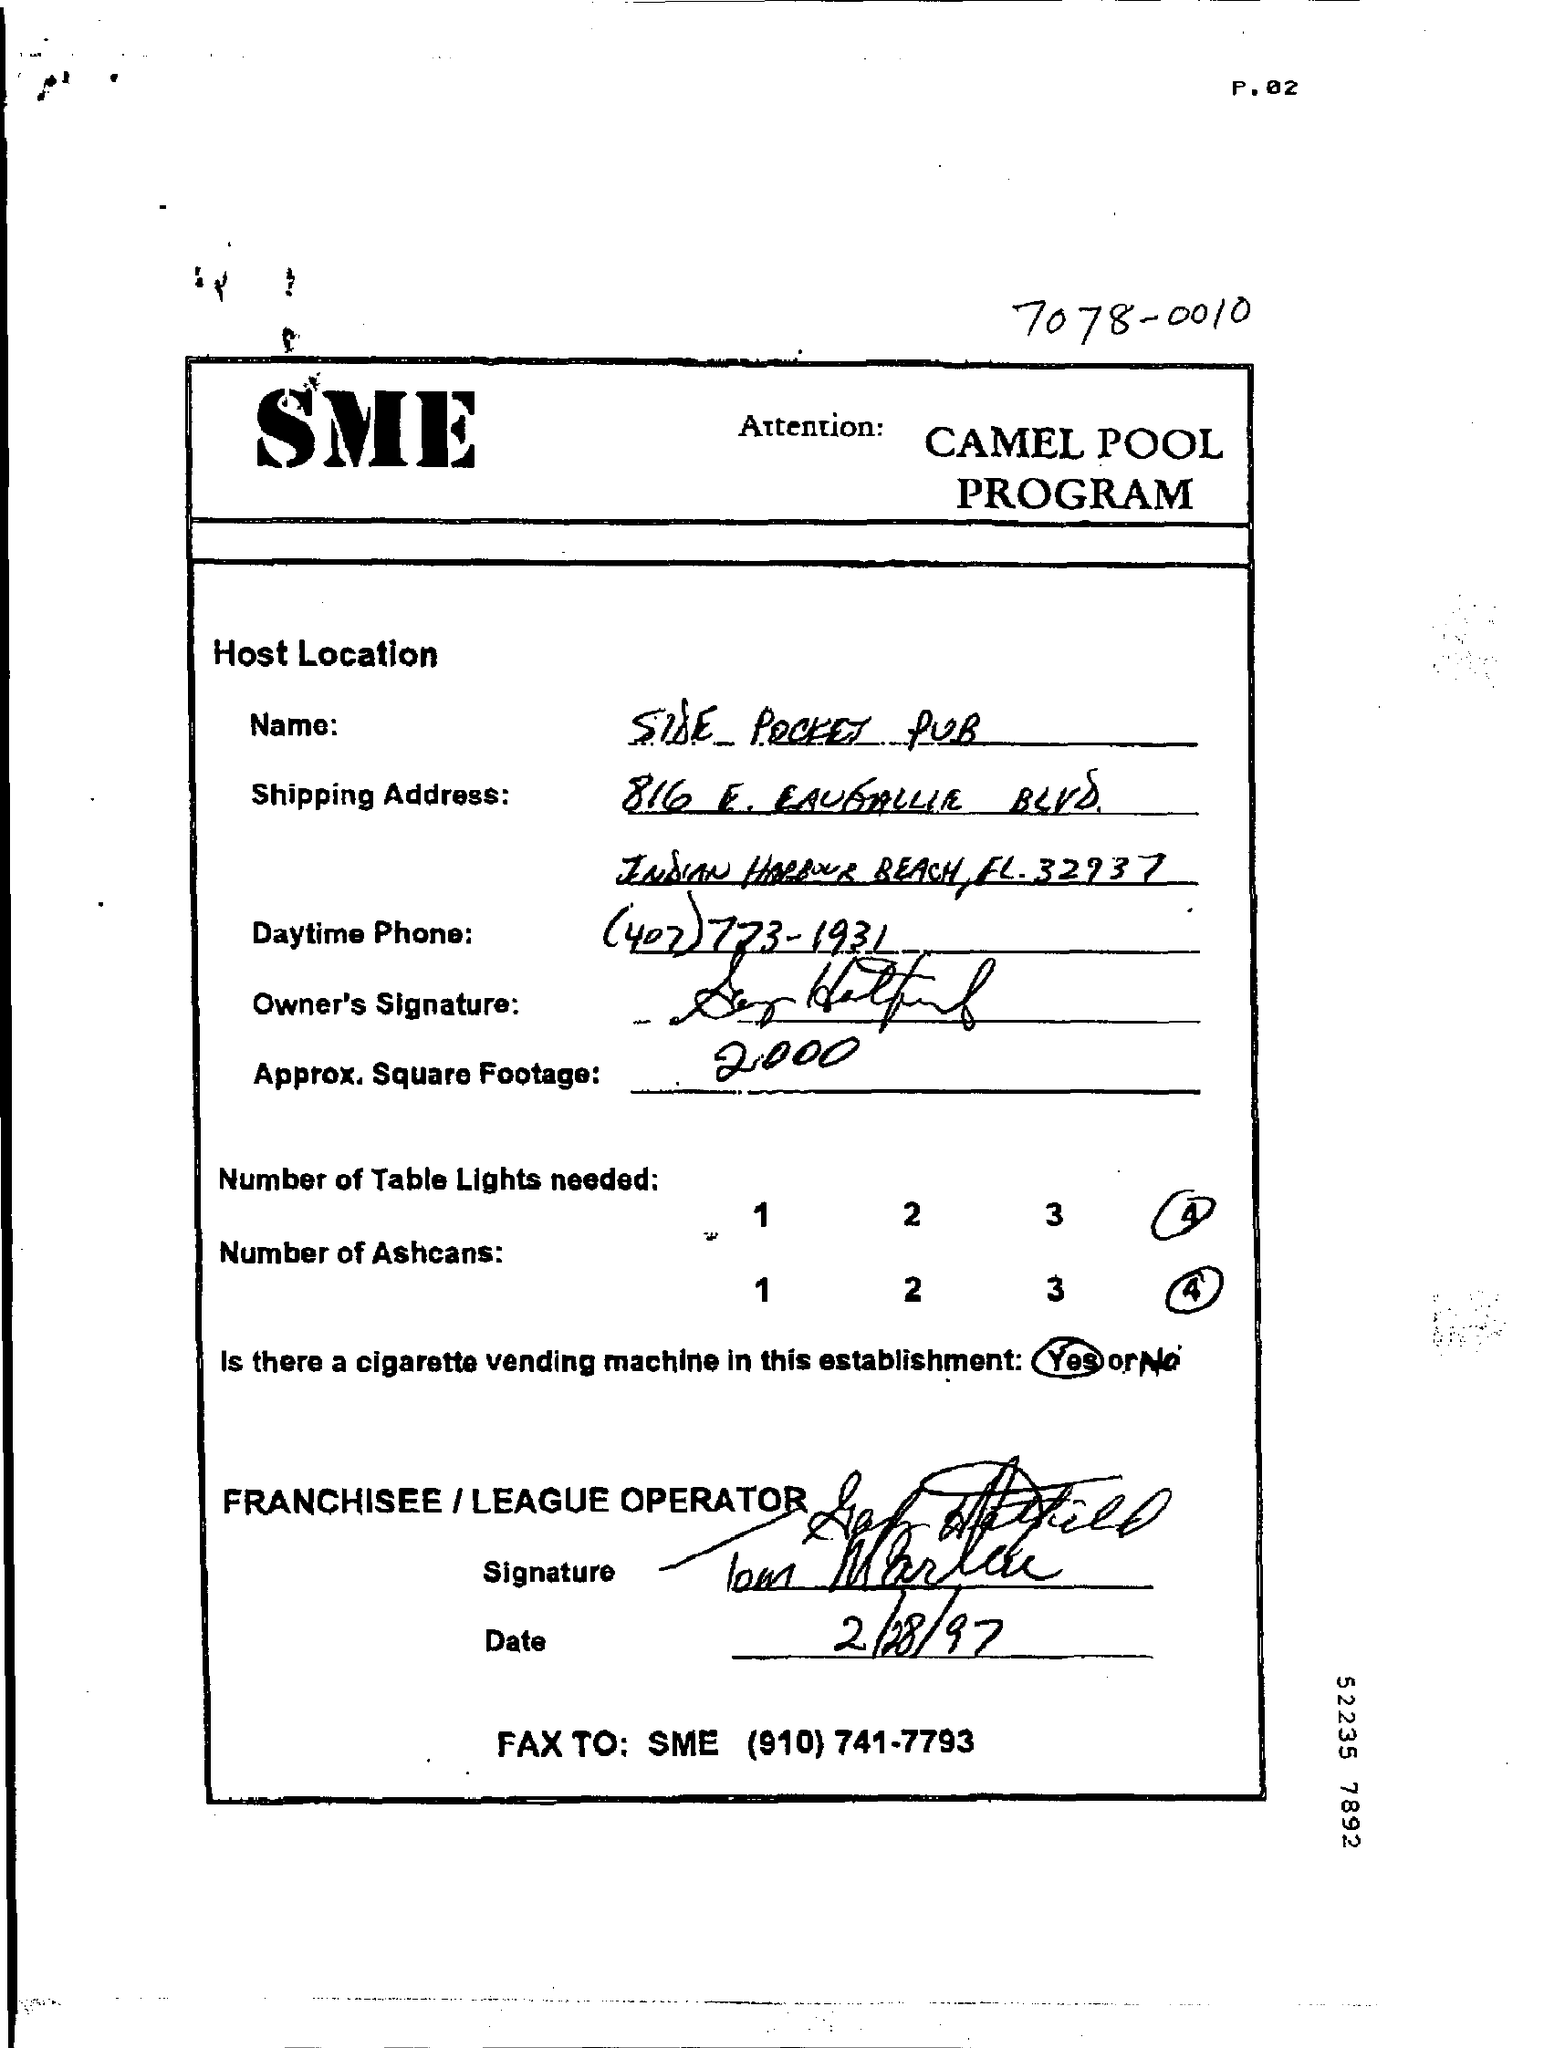What are the big bold letter on the top?
Offer a very short reply. SME. What is the date mentioned?
Your answer should be very brief. 2/28/97. What are the numbers Table Lights needed?
Your response must be concise. 4. What are the numbers of Ashcans needed?
Offer a very short reply. 4. 